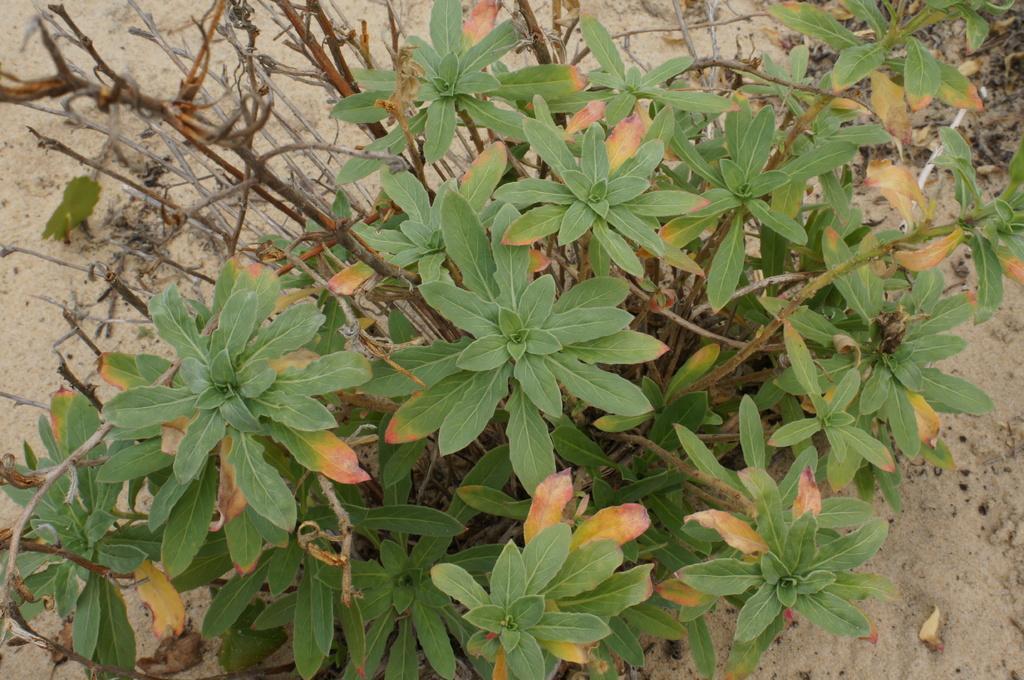How would you summarize this image in a sentence or two? In this image, I can see plants with stems and leaves. In the background, there is sand. 